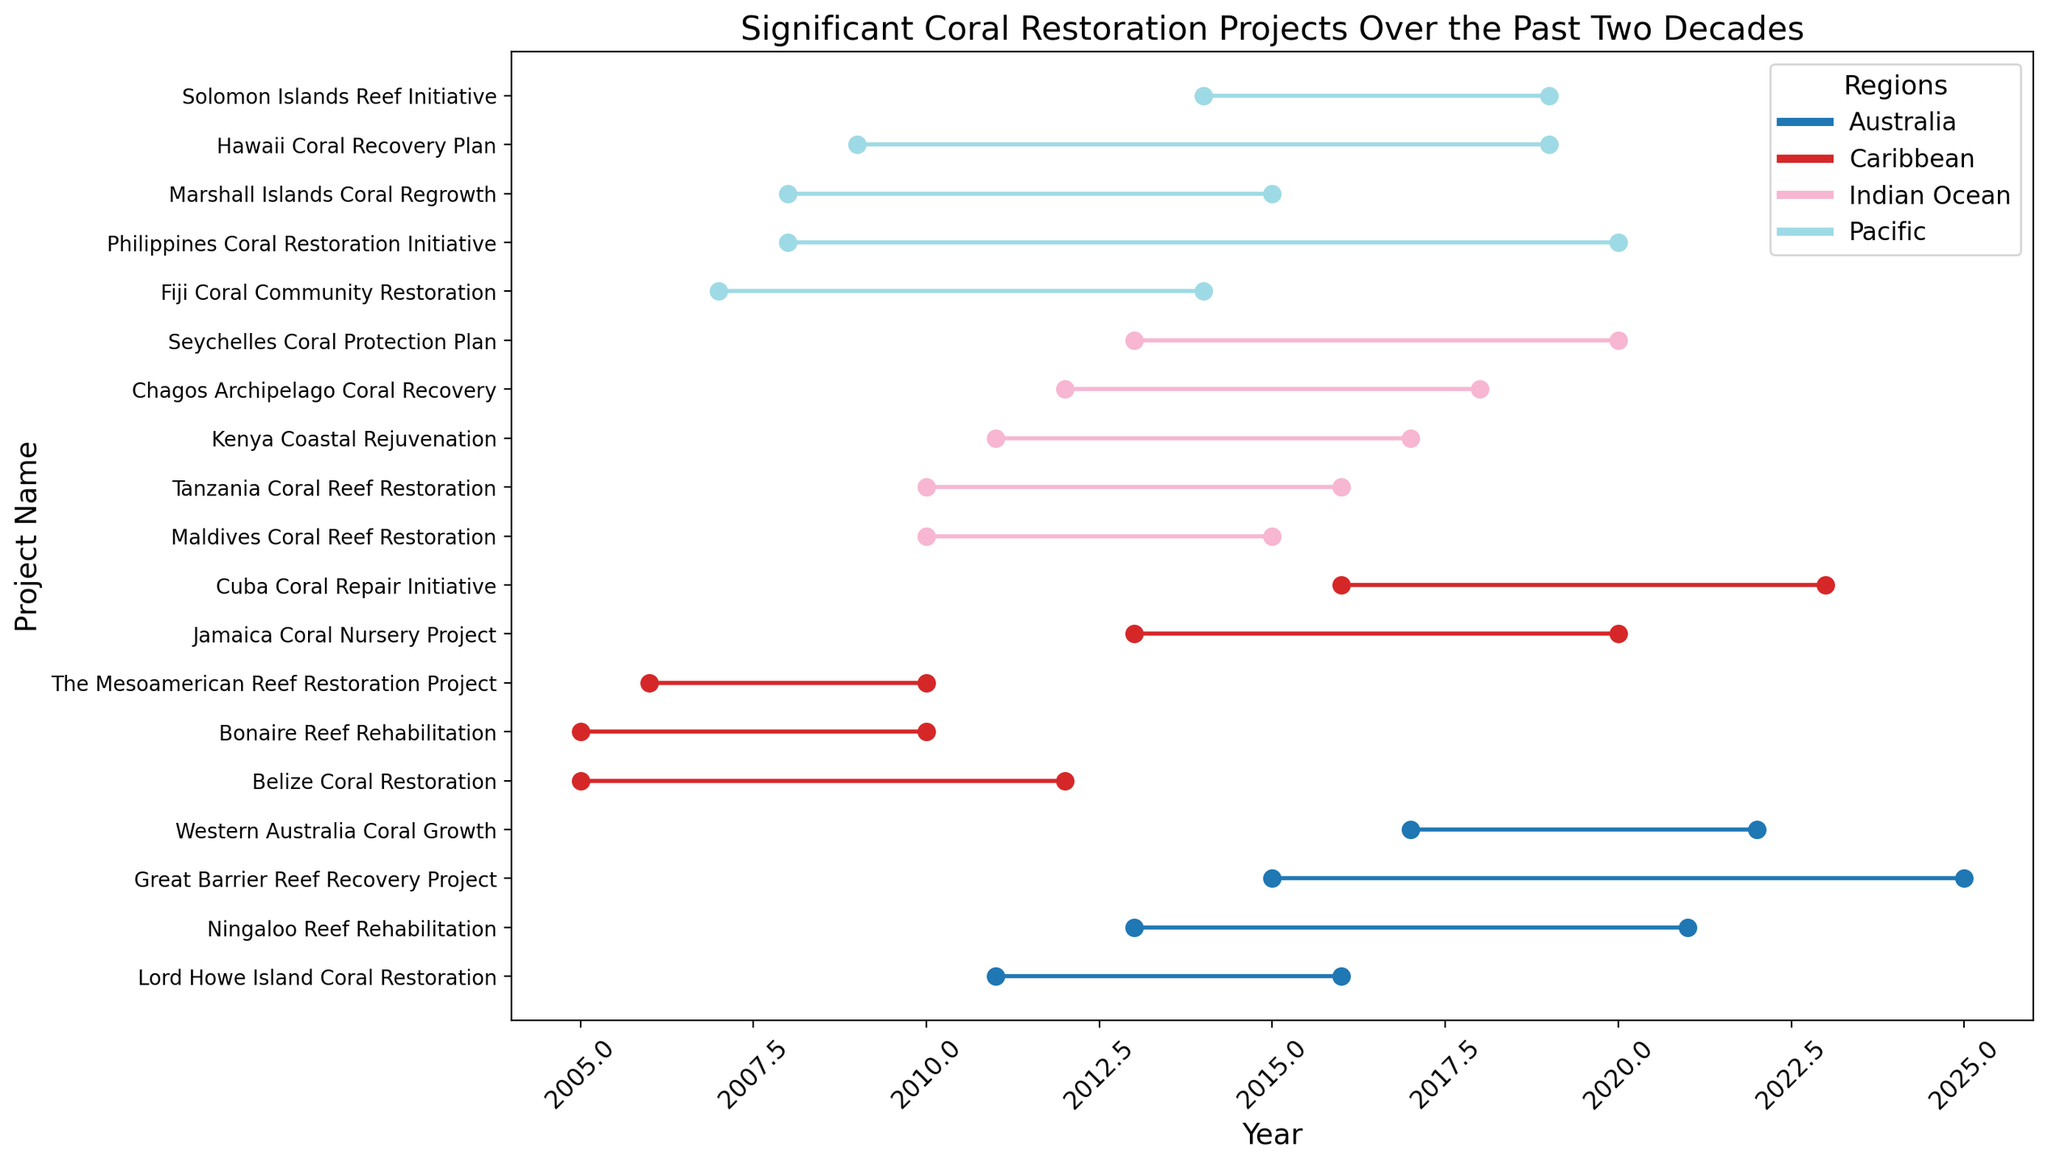What is the longest project duration in the Caribbean region? To determine the longest project duration in the Caribbean, look at the start and end years for each project in the region. The project with the years spanning the most time would be the longest. The "Cuba Coral Repair Initiative" runs from 2016 to 2023, resulting in a duration of 7 years.
Answer: Cuba Coral Repair Initiative (7 years) Which regions had coral restoration projects ending in 2020? Review the end years for all projects, and identify those that end in 2020. Four projects end in 2020: "Philippines Coral Restoration Initiative" in the Pacific, "Seychelles Coral Protection Plan" in the Indian Ocean, "Western Australia Coral Growth" in Australia, and "Jamaica Coral Nursery Project" in the Caribbean.
Answer: Pacific, Indian Ocean, Australia, Caribbean How many restoration projects are there in the Pacific region? Count the number of projects listed under the Pacific region. The visual plot shows there are 6 projects: "Philippines Coral Restoration Initiative," "Hawaii Coral Recovery Plan," "Fiji Coral Community Restoration," "Marshall Islands Coral Regrowth," "Solomon Islands Reef Initiative," and "Marshall Islands Coral Regrowth."
Answer: 6 Which project had the shortest duration? Find the project with the smallest difference between the start year and end year across all regions. The "Maldives Coral Reef Restoration" project in the Indian Ocean, running from 2010 to 2015, has a duration of only 5 years.
Answer: Maldives Coral Reef Restoration (5 years) Which region started the earliest coral restoration project? Look at the start years for each region and identify the earliest year. The Caribbean region started the earliest project with the "Belize Coral Restoration" in 2005.
Answer: Caribbean What is the average duration of the projects in the Australian region? For the Australia region, calculate the duration of each project: "Great Barrier Reef Recovery Project" (10 years), "Ningaloo Reef Rehabilitation" (8 years), "Lord Howe Island Coral Restoration" (5 years), and "Western Australia Coral Growth" (5 years). Sum these durations (10+8+5+5=28) and divide by the number of projects (4). The average duration is 7 years.
Answer: 7 years Compare the start years of "Belize Coral Restoration" and "Tanzania Coral Reef Restoration". Which started earlier? The "Belize Coral Restoration" started in 2005, and the "Tanzania Coral Reef Restoration" started in 2010. Therefore, the "Belize Coral Restoration" started earlier.
Answer: Belize Coral Restoration Which project in the Caribbean region had the latest start year? Among the projects in the Caribbean, identify the one with the latest start year. The "Cuba Coral Repair Initiative" started in 2016, the latest in the region.
Answer: Cuba Coral Repair Initiative Which project in the Pacific region continued until 2019? Review the end years for each Pacific project. The "Hawaii Coral Recovery Plan" and "Solomon Islands Reef Initiative" both ended in 2019.
Answer: Hawaii Coral Recovery Plan, Solomon Islands Reef Initiative 